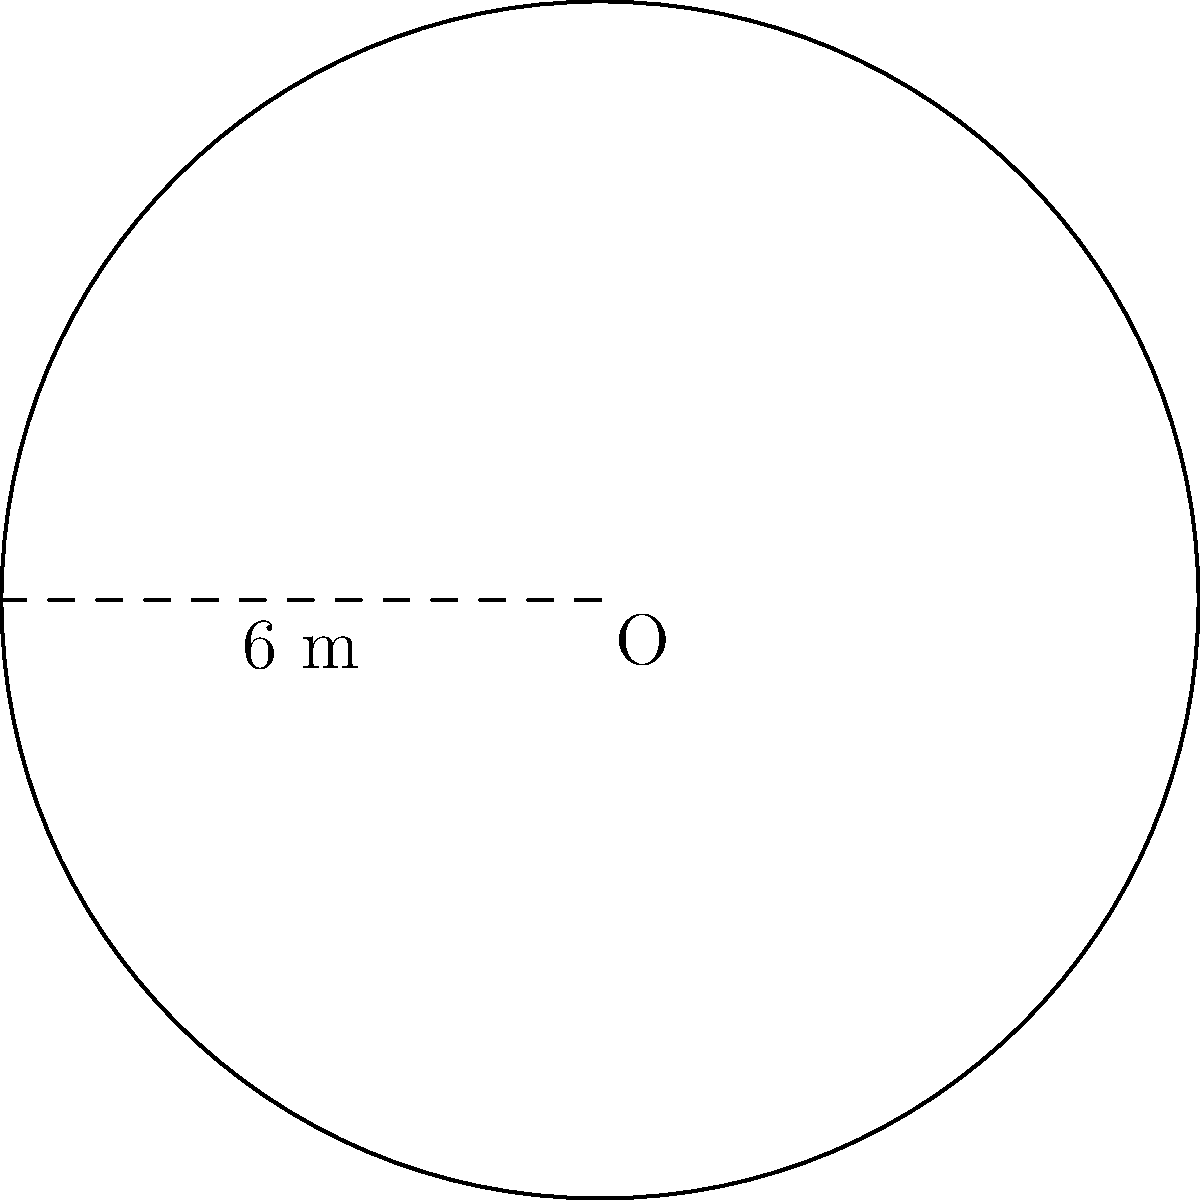In the anthropology exhibit, a circular artifact display platform needs to be constructed. If the radius of the platform is 6 meters, what is the total area of the platform? Round your answer to the nearest whole number. To find the area of a circular platform, we need to use the formula for the area of a circle:

1) The formula for the area of a circle is:
   $$A = \pi r^2$$
   where $A$ is the area and $r$ is the radius.

2) We're given that the radius is 6 meters.

3) Let's substitute this into our formula:
   $$A = \pi (6)^2$$

4) Simplify the exponent:
   $$A = \pi (36)$$

5) Multiply:
   $$A = 36\pi$$

6) Using 3.14159 as an approximation for $\pi$:
   $$A \approx 36 * 3.14159 = 113.09724$$

7) Rounding to the nearest whole number:
   $$A \approx 113 \text{ square meters}$$

Therefore, the total area of the circular artifact display platform is approximately 113 square meters.
Answer: 113 square meters 